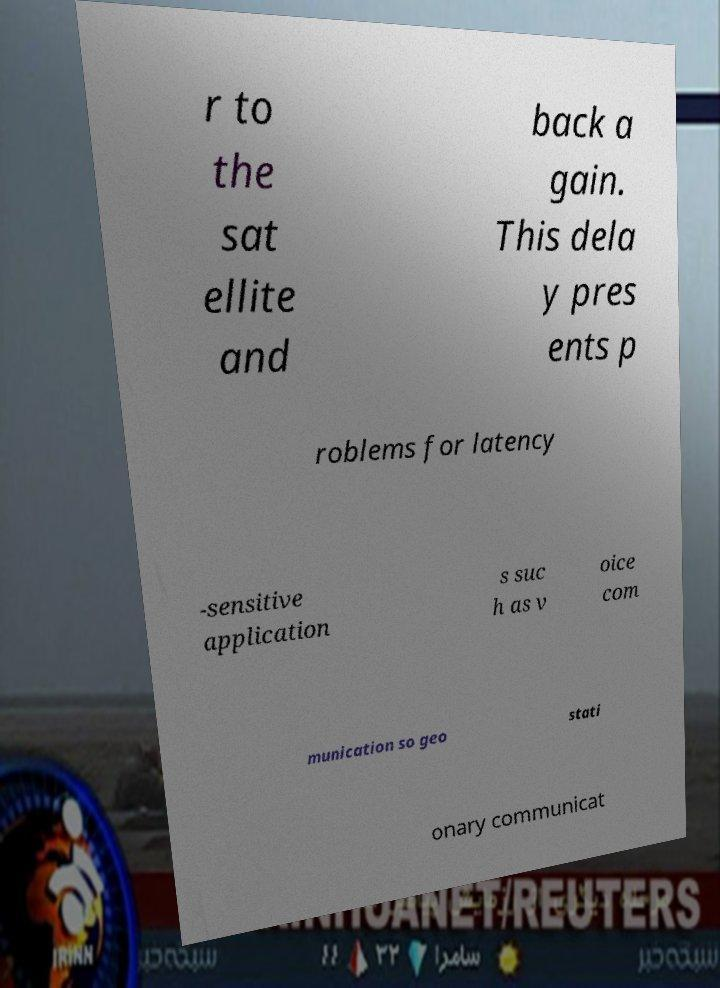Could you extract and type out the text from this image? r to the sat ellite and back a gain. This dela y pres ents p roblems for latency -sensitive application s suc h as v oice com munication so geo stati onary communicat 